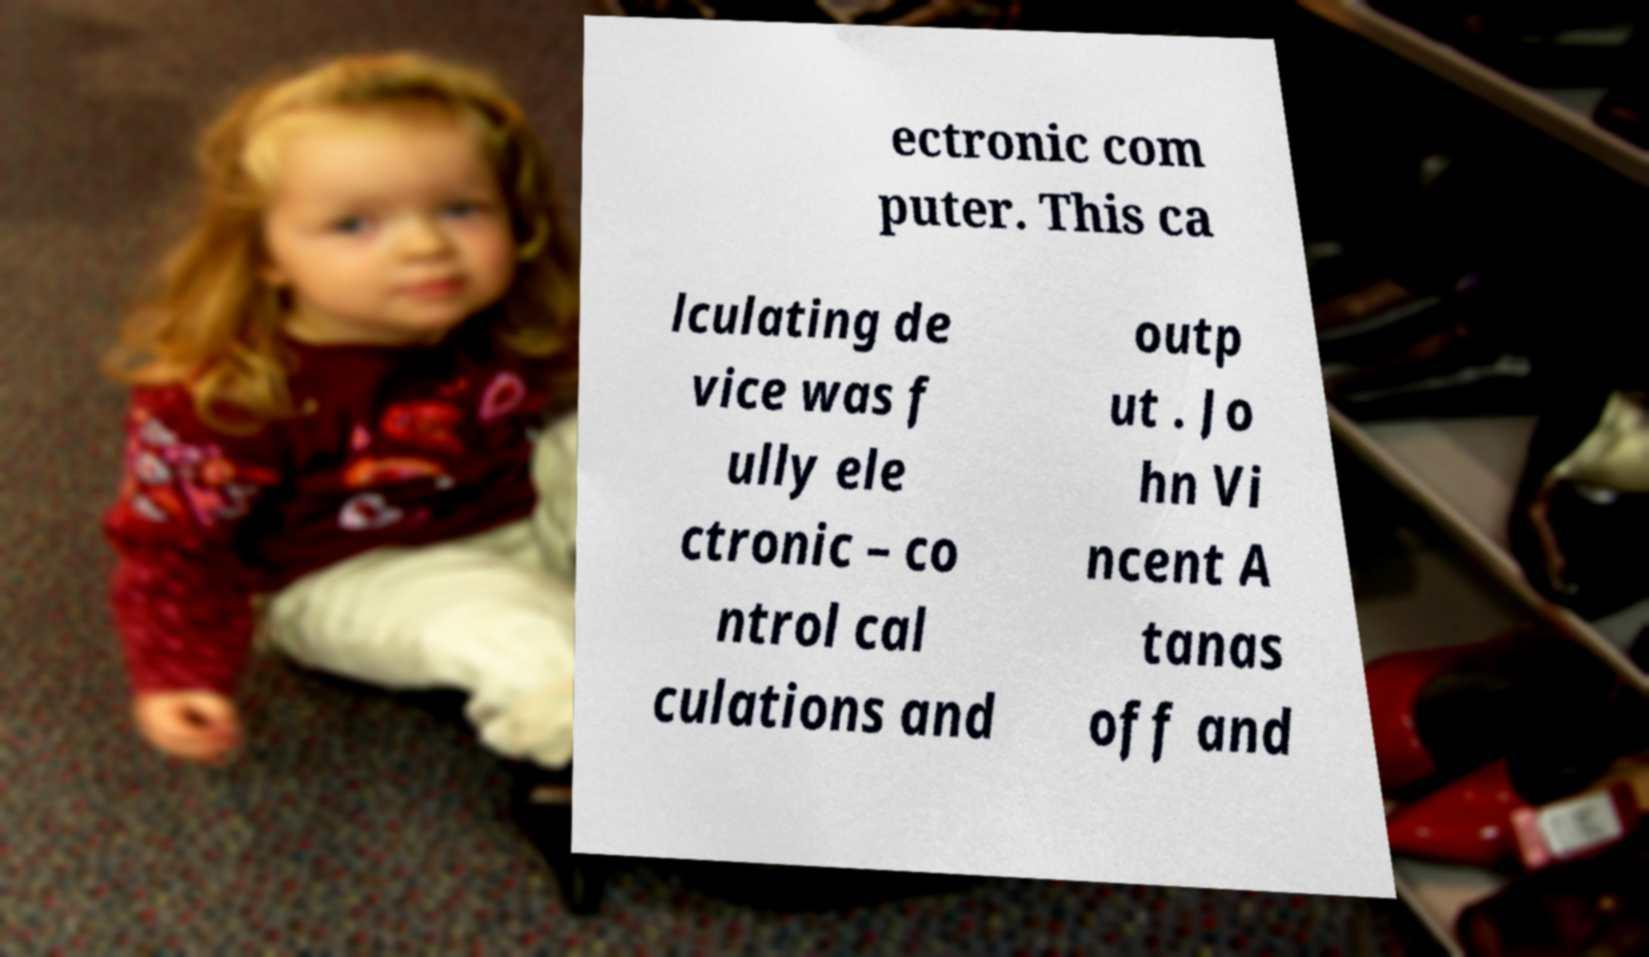Could you assist in decoding the text presented in this image and type it out clearly? ectronic com puter. This ca lculating de vice was f ully ele ctronic – co ntrol cal culations and outp ut . Jo hn Vi ncent A tanas off and 